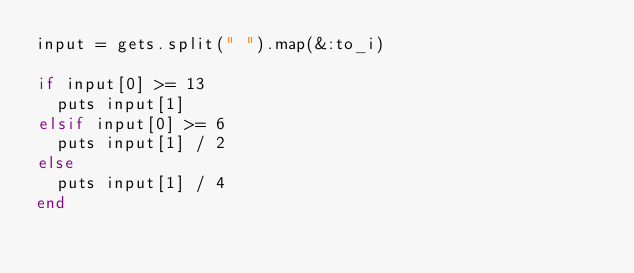Convert code to text. <code><loc_0><loc_0><loc_500><loc_500><_Ruby_>input = gets.split(" ").map(&:to_i)

if input[0] >= 13
  puts input[1]
elsif input[0] >= 6
  puts input[1] / 2
else
  puts input[1] / 4
end</code> 